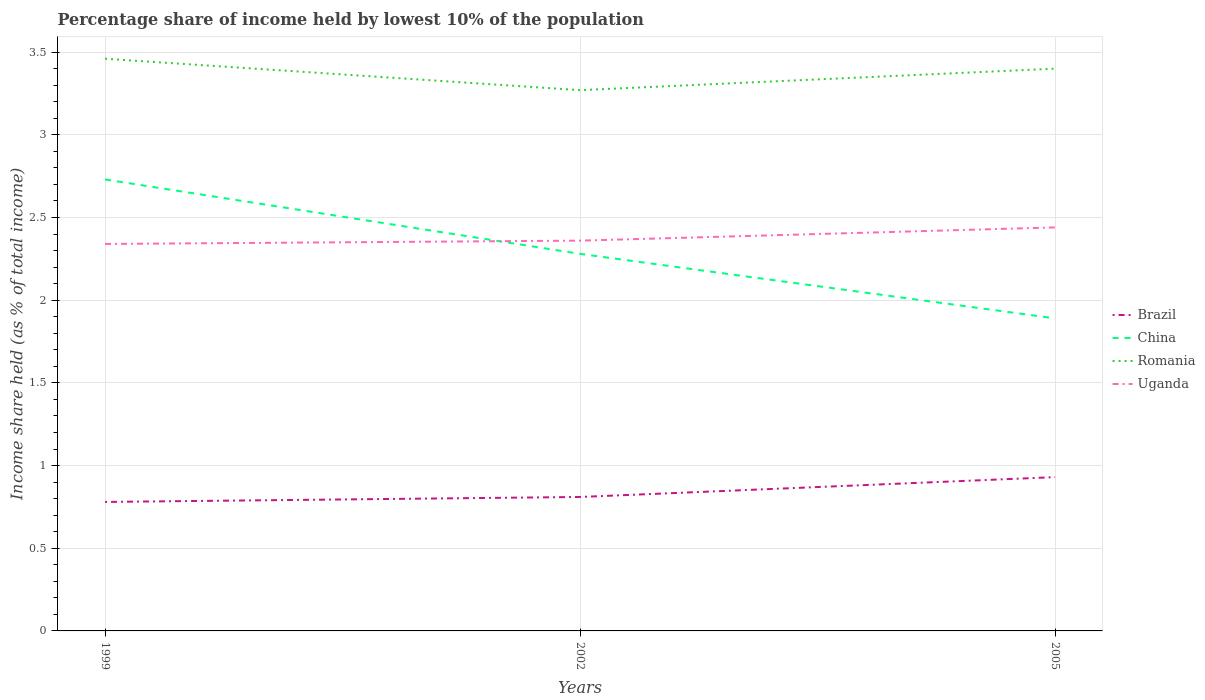Is the number of lines equal to the number of legend labels?
Offer a very short reply. Yes. Across all years, what is the maximum percentage share of income held by lowest 10% of the population in Uganda?
Make the answer very short. 2.34. What is the total percentage share of income held by lowest 10% of the population in China in the graph?
Provide a short and direct response. 0.39. What is the difference between the highest and the second highest percentage share of income held by lowest 10% of the population in Brazil?
Your answer should be very brief. 0.15. What is the difference between the highest and the lowest percentage share of income held by lowest 10% of the population in China?
Ensure brevity in your answer.  1. How many years are there in the graph?
Provide a short and direct response. 3. What is the difference between two consecutive major ticks on the Y-axis?
Your response must be concise. 0.5. Are the values on the major ticks of Y-axis written in scientific E-notation?
Give a very brief answer. No. How many legend labels are there?
Your answer should be compact. 4. What is the title of the graph?
Your answer should be compact. Percentage share of income held by lowest 10% of the population. What is the label or title of the X-axis?
Offer a terse response. Years. What is the label or title of the Y-axis?
Make the answer very short. Income share held (as % of total income). What is the Income share held (as % of total income) of Brazil in 1999?
Keep it short and to the point. 0.78. What is the Income share held (as % of total income) in China in 1999?
Your response must be concise. 2.73. What is the Income share held (as % of total income) in Romania in 1999?
Make the answer very short. 3.46. What is the Income share held (as % of total income) in Uganda in 1999?
Offer a terse response. 2.34. What is the Income share held (as % of total income) in Brazil in 2002?
Your answer should be compact. 0.81. What is the Income share held (as % of total income) in China in 2002?
Keep it short and to the point. 2.28. What is the Income share held (as % of total income) in Romania in 2002?
Offer a terse response. 3.27. What is the Income share held (as % of total income) in Uganda in 2002?
Give a very brief answer. 2.36. What is the Income share held (as % of total income) of China in 2005?
Provide a succinct answer. 1.89. What is the Income share held (as % of total income) of Uganda in 2005?
Your answer should be compact. 2.44. Across all years, what is the maximum Income share held (as % of total income) of China?
Make the answer very short. 2.73. Across all years, what is the maximum Income share held (as % of total income) of Romania?
Ensure brevity in your answer.  3.46. Across all years, what is the maximum Income share held (as % of total income) in Uganda?
Keep it short and to the point. 2.44. Across all years, what is the minimum Income share held (as % of total income) of Brazil?
Ensure brevity in your answer.  0.78. Across all years, what is the minimum Income share held (as % of total income) in China?
Provide a succinct answer. 1.89. Across all years, what is the minimum Income share held (as % of total income) in Romania?
Your response must be concise. 3.27. Across all years, what is the minimum Income share held (as % of total income) in Uganda?
Provide a succinct answer. 2.34. What is the total Income share held (as % of total income) of Brazil in the graph?
Ensure brevity in your answer.  2.52. What is the total Income share held (as % of total income) of Romania in the graph?
Make the answer very short. 10.13. What is the total Income share held (as % of total income) of Uganda in the graph?
Provide a short and direct response. 7.14. What is the difference between the Income share held (as % of total income) of Brazil in 1999 and that in 2002?
Provide a succinct answer. -0.03. What is the difference between the Income share held (as % of total income) of China in 1999 and that in 2002?
Provide a short and direct response. 0.45. What is the difference between the Income share held (as % of total income) in Romania in 1999 and that in 2002?
Your answer should be compact. 0.19. What is the difference between the Income share held (as % of total income) in Uganda in 1999 and that in 2002?
Ensure brevity in your answer.  -0.02. What is the difference between the Income share held (as % of total income) of Brazil in 1999 and that in 2005?
Ensure brevity in your answer.  -0.15. What is the difference between the Income share held (as % of total income) in China in 1999 and that in 2005?
Your response must be concise. 0.84. What is the difference between the Income share held (as % of total income) in Romania in 1999 and that in 2005?
Your response must be concise. 0.06. What is the difference between the Income share held (as % of total income) of Uganda in 1999 and that in 2005?
Provide a succinct answer. -0.1. What is the difference between the Income share held (as % of total income) of Brazil in 2002 and that in 2005?
Make the answer very short. -0.12. What is the difference between the Income share held (as % of total income) of China in 2002 and that in 2005?
Give a very brief answer. 0.39. What is the difference between the Income share held (as % of total income) of Romania in 2002 and that in 2005?
Your response must be concise. -0.13. What is the difference between the Income share held (as % of total income) of Uganda in 2002 and that in 2005?
Provide a short and direct response. -0.08. What is the difference between the Income share held (as % of total income) in Brazil in 1999 and the Income share held (as % of total income) in Romania in 2002?
Give a very brief answer. -2.49. What is the difference between the Income share held (as % of total income) of Brazil in 1999 and the Income share held (as % of total income) of Uganda in 2002?
Your answer should be very brief. -1.58. What is the difference between the Income share held (as % of total income) of China in 1999 and the Income share held (as % of total income) of Romania in 2002?
Your answer should be very brief. -0.54. What is the difference between the Income share held (as % of total income) of China in 1999 and the Income share held (as % of total income) of Uganda in 2002?
Offer a terse response. 0.37. What is the difference between the Income share held (as % of total income) of Romania in 1999 and the Income share held (as % of total income) of Uganda in 2002?
Offer a very short reply. 1.1. What is the difference between the Income share held (as % of total income) in Brazil in 1999 and the Income share held (as % of total income) in China in 2005?
Offer a very short reply. -1.11. What is the difference between the Income share held (as % of total income) of Brazil in 1999 and the Income share held (as % of total income) of Romania in 2005?
Your response must be concise. -2.62. What is the difference between the Income share held (as % of total income) of Brazil in 1999 and the Income share held (as % of total income) of Uganda in 2005?
Offer a very short reply. -1.66. What is the difference between the Income share held (as % of total income) in China in 1999 and the Income share held (as % of total income) in Romania in 2005?
Make the answer very short. -0.67. What is the difference between the Income share held (as % of total income) in China in 1999 and the Income share held (as % of total income) in Uganda in 2005?
Offer a terse response. 0.29. What is the difference between the Income share held (as % of total income) of Romania in 1999 and the Income share held (as % of total income) of Uganda in 2005?
Ensure brevity in your answer.  1.02. What is the difference between the Income share held (as % of total income) of Brazil in 2002 and the Income share held (as % of total income) of China in 2005?
Ensure brevity in your answer.  -1.08. What is the difference between the Income share held (as % of total income) in Brazil in 2002 and the Income share held (as % of total income) in Romania in 2005?
Keep it short and to the point. -2.59. What is the difference between the Income share held (as % of total income) in Brazil in 2002 and the Income share held (as % of total income) in Uganda in 2005?
Offer a terse response. -1.63. What is the difference between the Income share held (as % of total income) in China in 2002 and the Income share held (as % of total income) in Romania in 2005?
Provide a succinct answer. -1.12. What is the difference between the Income share held (as % of total income) in China in 2002 and the Income share held (as % of total income) in Uganda in 2005?
Provide a short and direct response. -0.16. What is the difference between the Income share held (as % of total income) in Romania in 2002 and the Income share held (as % of total income) in Uganda in 2005?
Your answer should be very brief. 0.83. What is the average Income share held (as % of total income) of Brazil per year?
Make the answer very short. 0.84. What is the average Income share held (as % of total income) of China per year?
Make the answer very short. 2.3. What is the average Income share held (as % of total income) of Romania per year?
Your response must be concise. 3.38. What is the average Income share held (as % of total income) of Uganda per year?
Your answer should be very brief. 2.38. In the year 1999, what is the difference between the Income share held (as % of total income) in Brazil and Income share held (as % of total income) in China?
Ensure brevity in your answer.  -1.95. In the year 1999, what is the difference between the Income share held (as % of total income) in Brazil and Income share held (as % of total income) in Romania?
Offer a very short reply. -2.68. In the year 1999, what is the difference between the Income share held (as % of total income) of Brazil and Income share held (as % of total income) of Uganda?
Your answer should be compact. -1.56. In the year 1999, what is the difference between the Income share held (as % of total income) of China and Income share held (as % of total income) of Romania?
Give a very brief answer. -0.73. In the year 1999, what is the difference between the Income share held (as % of total income) in China and Income share held (as % of total income) in Uganda?
Your response must be concise. 0.39. In the year 1999, what is the difference between the Income share held (as % of total income) of Romania and Income share held (as % of total income) of Uganda?
Keep it short and to the point. 1.12. In the year 2002, what is the difference between the Income share held (as % of total income) in Brazil and Income share held (as % of total income) in China?
Provide a short and direct response. -1.47. In the year 2002, what is the difference between the Income share held (as % of total income) of Brazil and Income share held (as % of total income) of Romania?
Provide a succinct answer. -2.46. In the year 2002, what is the difference between the Income share held (as % of total income) of Brazil and Income share held (as % of total income) of Uganda?
Your response must be concise. -1.55. In the year 2002, what is the difference between the Income share held (as % of total income) in China and Income share held (as % of total income) in Romania?
Offer a very short reply. -0.99. In the year 2002, what is the difference between the Income share held (as % of total income) of China and Income share held (as % of total income) of Uganda?
Provide a short and direct response. -0.08. In the year 2002, what is the difference between the Income share held (as % of total income) in Romania and Income share held (as % of total income) in Uganda?
Your answer should be compact. 0.91. In the year 2005, what is the difference between the Income share held (as % of total income) in Brazil and Income share held (as % of total income) in China?
Provide a short and direct response. -0.96. In the year 2005, what is the difference between the Income share held (as % of total income) of Brazil and Income share held (as % of total income) of Romania?
Your answer should be very brief. -2.47. In the year 2005, what is the difference between the Income share held (as % of total income) of Brazil and Income share held (as % of total income) of Uganda?
Your response must be concise. -1.51. In the year 2005, what is the difference between the Income share held (as % of total income) of China and Income share held (as % of total income) of Romania?
Your answer should be very brief. -1.51. In the year 2005, what is the difference between the Income share held (as % of total income) of China and Income share held (as % of total income) of Uganda?
Make the answer very short. -0.55. What is the ratio of the Income share held (as % of total income) of Brazil in 1999 to that in 2002?
Your answer should be very brief. 0.96. What is the ratio of the Income share held (as % of total income) of China in 1999 to that in 2002?
Your answer should be very brief. 1.2. What is the ratio of the Income share held (as % of total income) of Romania in 1999 to that in 2002?
Offer a very short reply. 1.06. What is the ratio of the Income share held (as % of total income) in Uganda in 1999 to that in 2002?
Your response must be concise. 0.99. What is the ratio of the Income share held (as % of total income) of Brazil in 1999 to that in 2005?
Your response must be concise. 0.84. What is the ratio of the Income share held (as % of total income) of China in 1999 to that in 2005?
Your response must be concise. 1.44. What is the ratio of the Income share held (as % of total income) of Romania in 1999 to that in 2005?
Make the answer very short. 1.02. What is the ratio of the Income share held (as % of total income) in Uganda in 1999 to that in 2005?
Provide a succinct answer. 0.96. What is the ratio of the Income share held (as % of total income) of Brazil in 2002 to that in 2005?
Your answer should be very brief. 0.87. What is the ratio of the Income share held (as % of total income) of China in 2002 to that in 2005?
Your response must be concise. 1.21. What is the ratio of the Income share held (as % of total income) in Romania in 2002 to that in 2005?
Give a very brief answer. 0.96. What is the ratio of the Income share held (as % of total income) of Uganda in 2002 to that in 2005?
Offer a terse response. 0.97. What is the difference between the highest and the second highest Income share held (as % of total income) in Brazil?
Make the answer very short. 0.12. What is the difference between the highest and the second highest Income share held (as % of total income) in China?
Ensure brevity in your answer.  0.45. What is the difference between the highest and the second highest Income share held (as % of total income) of Romania?
Offer a terse response. 0.06. What is the difference between the highest and the lowest Income share held (as % of total income) in China?
Ensure brevity in your answer.  0.84. What is the difference between the highest and the lowest Income share held (as % of total income) in Romania?
Ensure brevity in your answer.  0.19. 